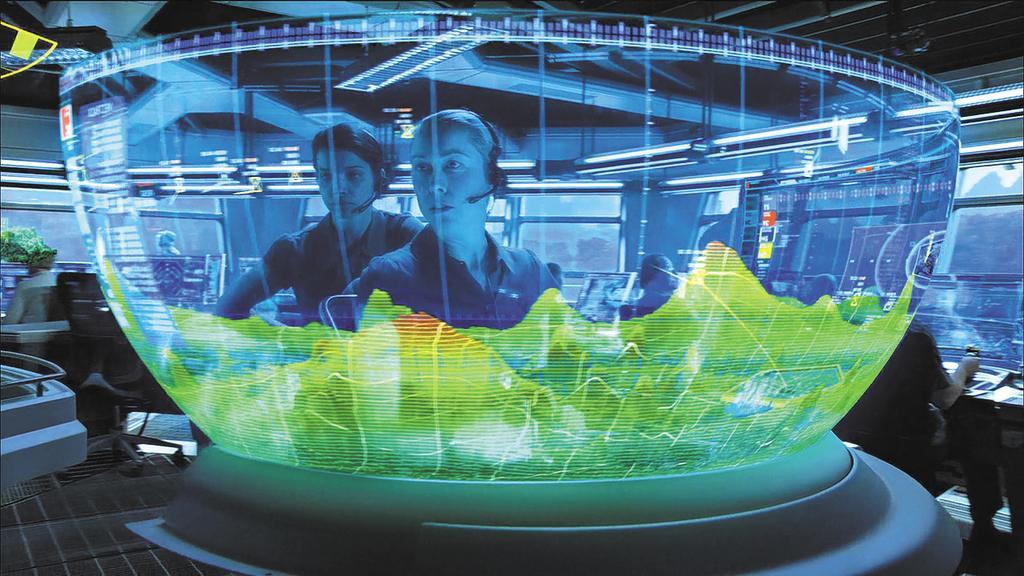Could you give a brief overview of what you see in this image? In this image I can see a group of people, chairs, houseplant and tables on the floor. At the top I can see a rooftop. This image is taken may be in a hall. 